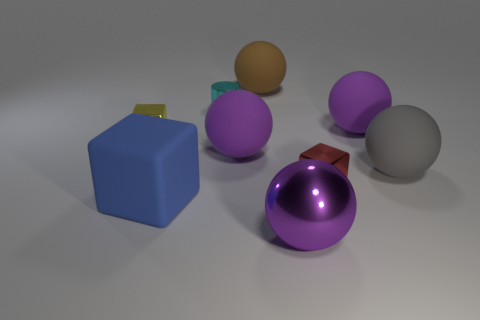Subtract all brown cubes. How many purple balls are left? 3 Subtract 2 balls. How many balls are left? 3 Subtract all gray balls. How many balls are left? 4 Subtract all brown spheres. How many spheres are left? 4 Subtract all red balls. Subtract all blue cubes. How many balls are left? 5 Add 1 tiny blue things. How many objects exist? 10 Subtract all cylinders. How many objects are left? 8 Add 6 small green things. How many small green things exist? 6 Subtract 0 green cylinders. How many objects are left? 9 Subtract all green cubes. Subtract all small cyan things. How many objects are left? 8 